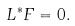Convert formula to latex. <formula><loc_0><loc_0><loc_500><loc_500>L ^ { \ast } F = 0 .</formula> 